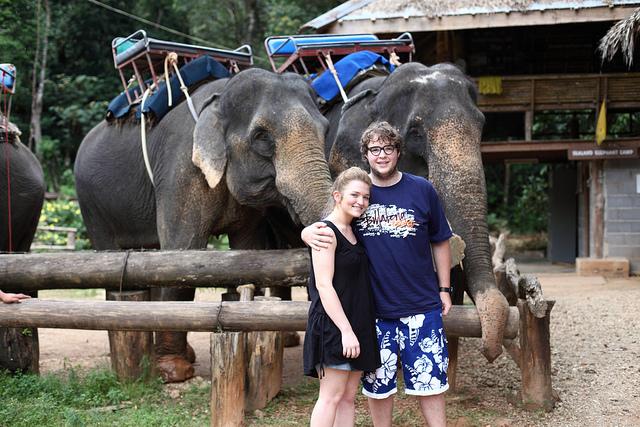Are they married couple?
Answer briefly. Yes. Did they ride on an elephant?
Short answer required. Yes. What color is his shirt?
Write a very short answer. Blue. 